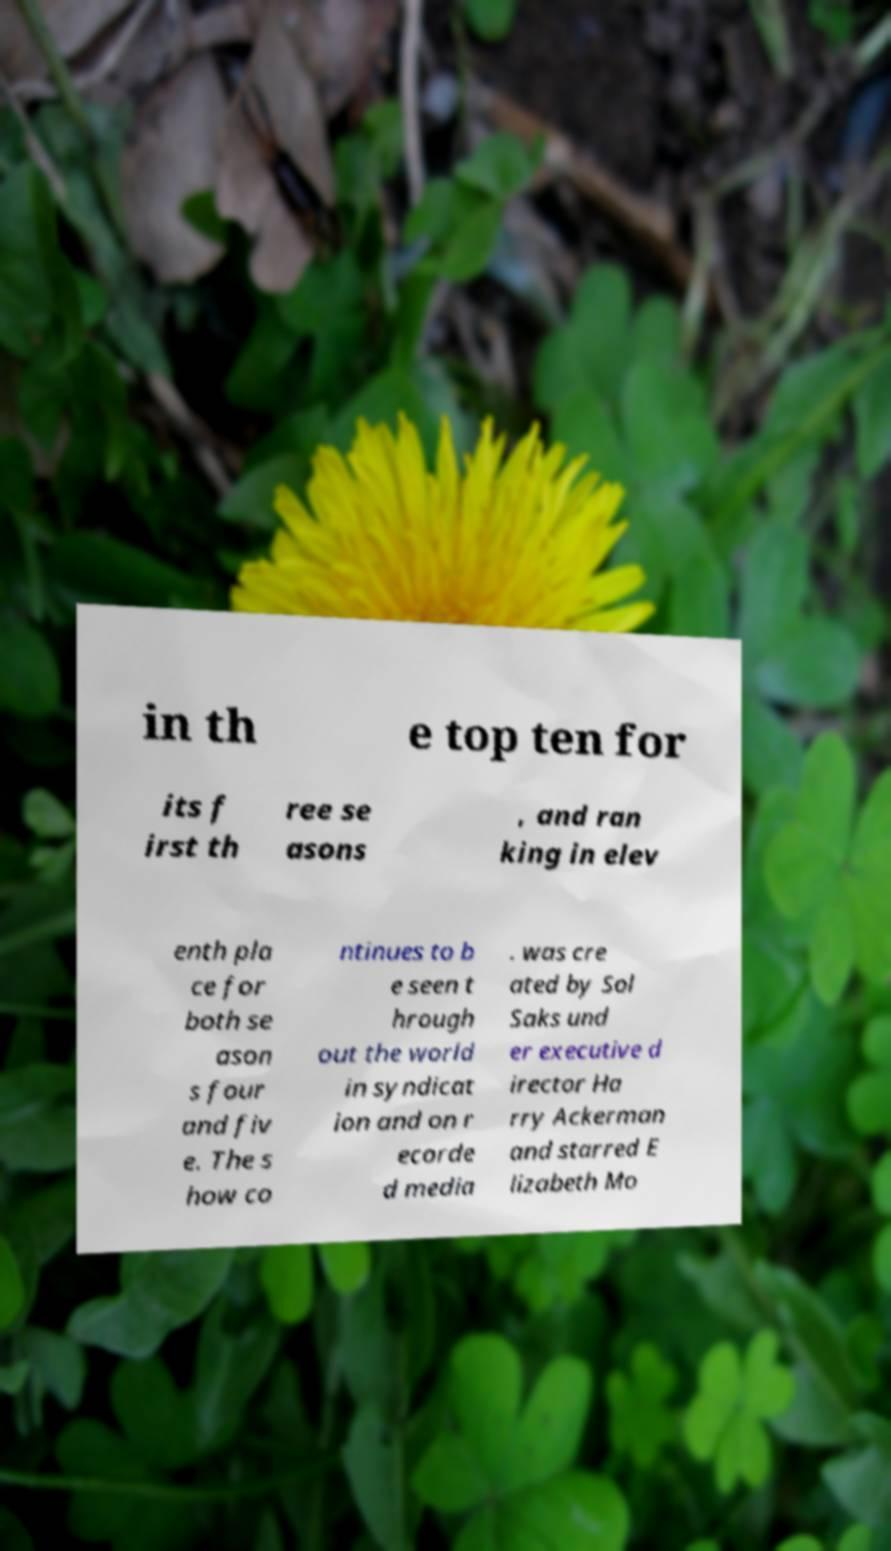What messages or text are displayed in this image? I need them in a readable, typed format. in th e top ten for its f irst th ree se asons , and ran king in elev enth pla ce for both se ason s four and fiv e. The s how co ntinues to b e seen t hrough out the world in syndicat ion and on r ecorde d media . was cre ated by Sol Saks und er executive d irector Ha rry Ackerman and starred E lizabeth Mo 